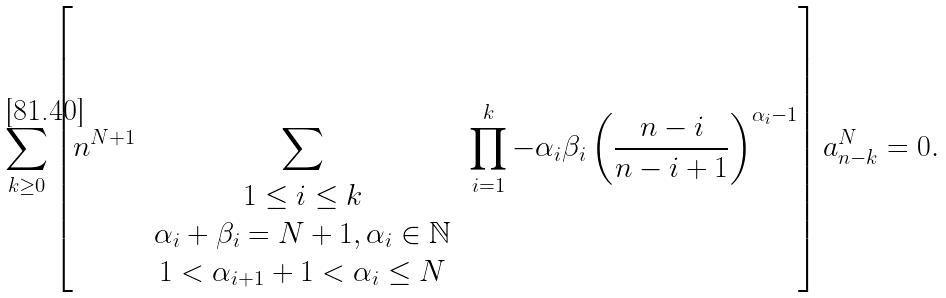<formula> <loc_0><loc_0><loc_500><loc_500>\sum _ { k \geq 0 } \left [ n ^ { N + 1 } \, \sum _ { \begin{array} { c } 1 \leq i \leq k \\ \alpha _ { i } + \beta _ { i } = N + 1 , \alpha _ { i } \in \mathbb { N } \\ 1 < \alpha _ { i + 1 } + 1 < \alpha _ { i } \leq N \end{array} } \, \prod _ { i = 1 } ^ { k } - \alpha _ { i } \beta _ { i } \left ( \frac { n - i } { n - i + 1 } \right ) ^ { \alpha _ { i } - 1 } \right ] a _ { n - k } ^ { N } = 0 .</formula> 